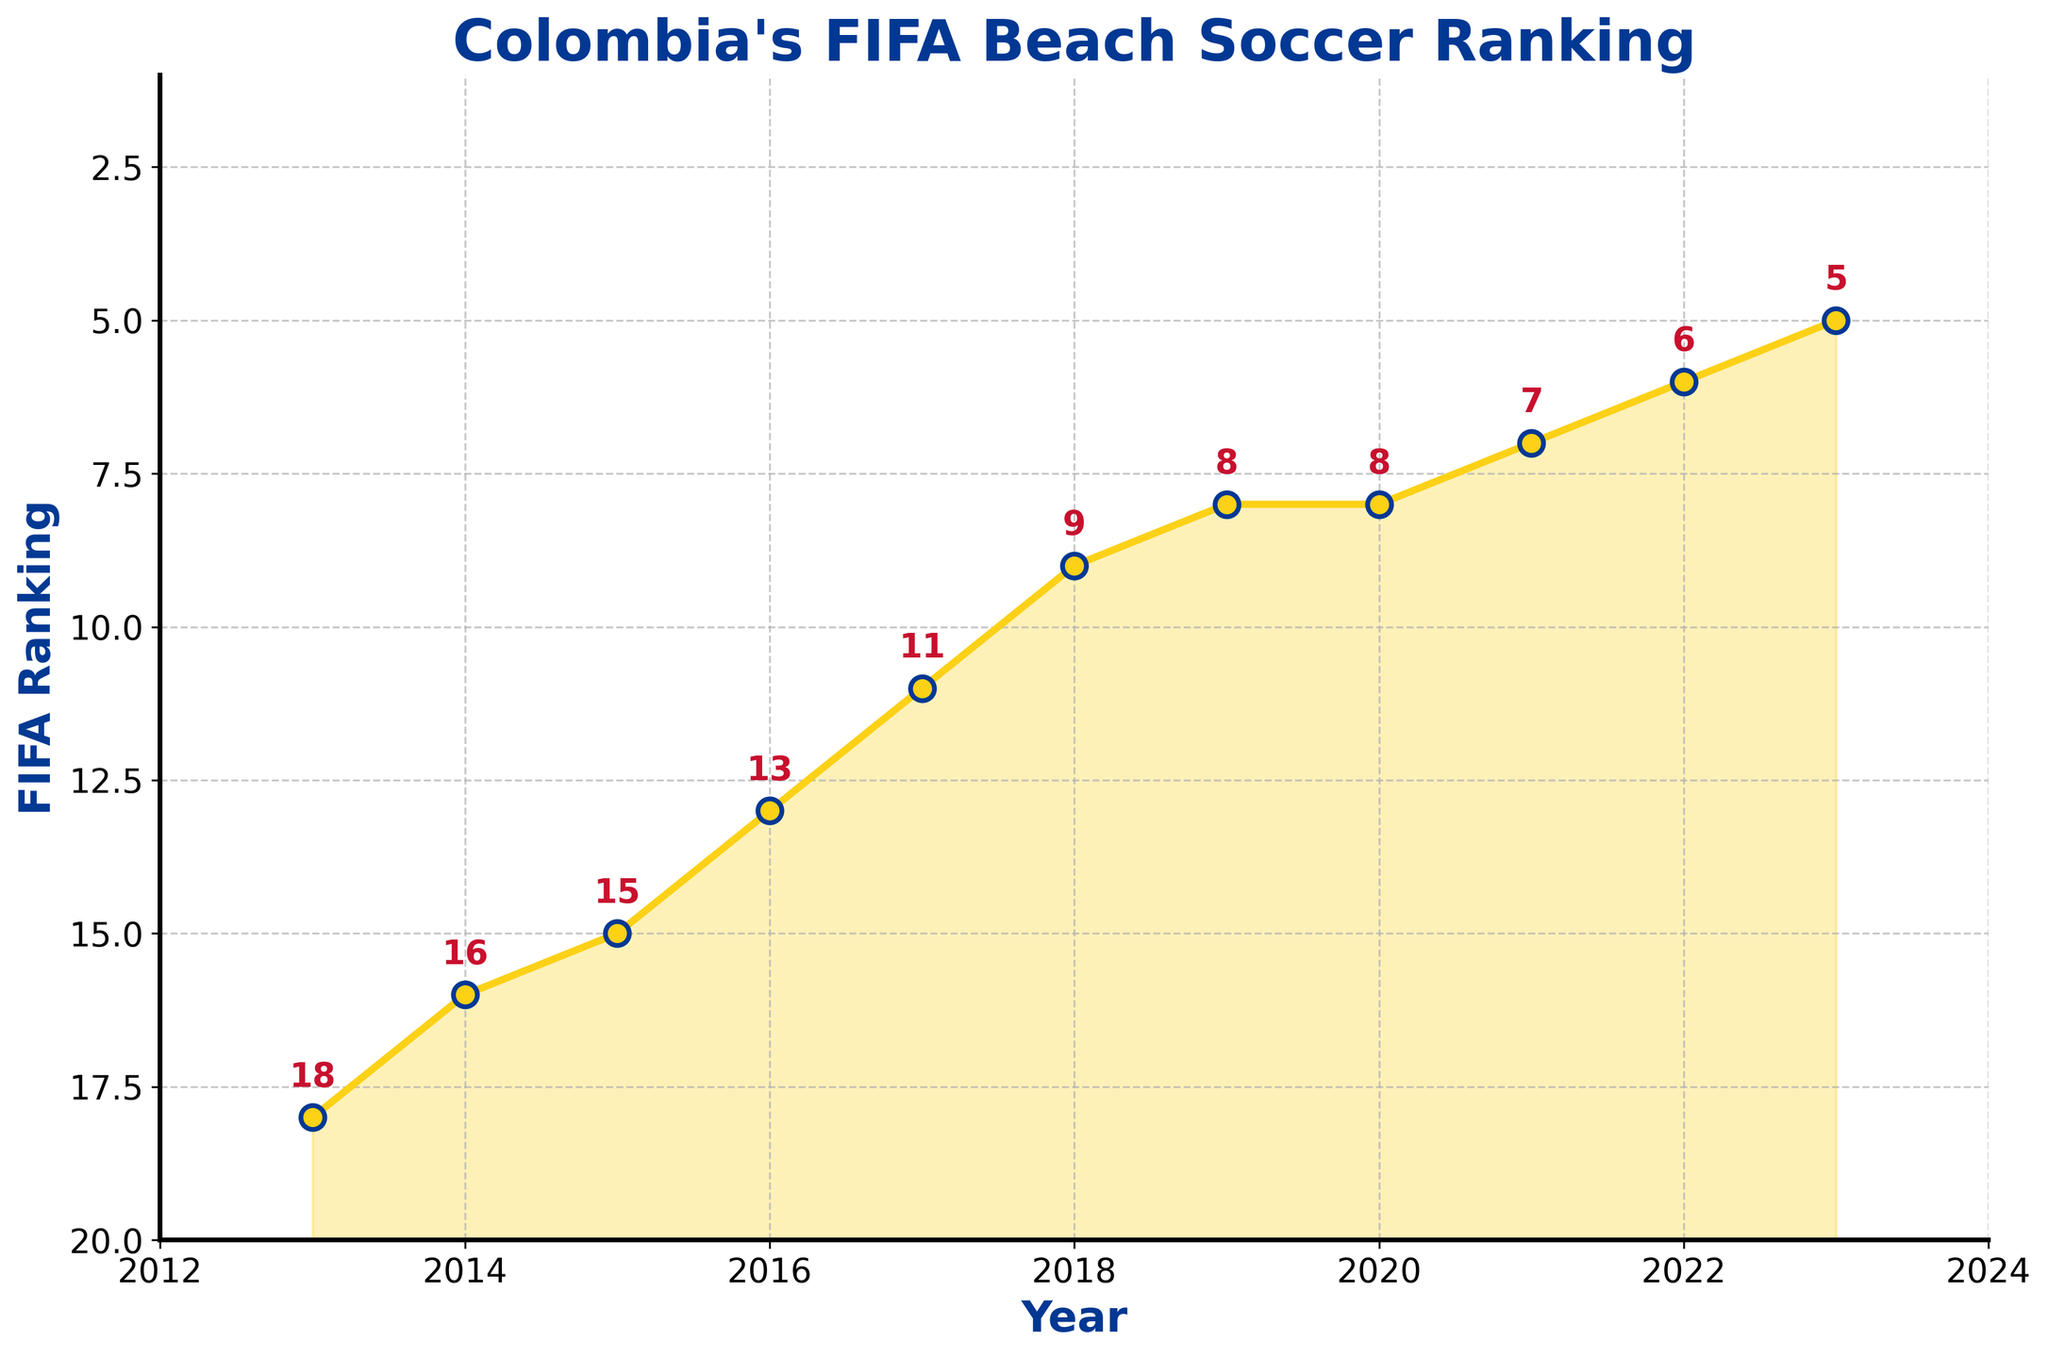What's the highest FIFA ranking that Colombia's beach soccer team achieved over the last decade? Looking at the figure, the lowest point on the y-axis which indicates the best ranking is in the year 2023, labeled as 5.
Answer: 5 How many years did Colombia maintain the same FIFA ranking without progressing or regressing? Observing the data points, Colombia maintained the same ranking for two consecutive years from 2019 to 2020, both at 8.
Answer: 2 years (2019-2020) Which year shows the most significant improvement in ranking compared to the previous year? From 2017 to 2018, Colombia's ranking improved from 11 to 9, which is a jump of 2 ranks. This is the largest improvement in a single year.
Answer: 2018 On average, how much did Colombia's ranking improve per year over the decade? Over 10 years (from 2013 to 2023), Colombia's ranking improved from 18 to 5, which is a total improvement of 13 ranks. Dividing this by the 10-year span, the average improvement is 1.3 ranks per year.
Answer: 1.3 ranks/year In which year did Colombia enter the top 10 FIFA rankings for beach soccer for the first time? Colombia first entered the top 10 in the year 2018 when their ranking improved to 9.
Answer: 2018 Compare Colombia's FIFA ranking progression between 2013 to 2017 and 2018 to 2023. Which period had a steeper trend of improvement? From 2013 to 2017, the ranking improved from 18 to 11 (7 ranks in total). From 2018 to 2023, the ranking improved from 9 to 5 (4 ranks in total). The first period (2013-2017) had a steeper improvement (7 ranks) compared to the second period (2018-2023) (4 ranks).
Answer: 2013-2017 How many times did Colombia rank slower than 10th place over the decade? Colombia ranked slower than 10th place from 2013 to 2017. This includes 5 years (2013, 2014, 2015, 2016, 2017).
Answer: 5 times What is the total number of years Colombia's FIFA ranking was in the single digits? Colombia's ranking was in the single digits from 2018 to 2023, which is 6 years.
Answer: 6 years What is the trend observed in Colombia's FIFA beach soccer rankings from 2013 to 2023? The trend shows a consistent improvement in Colombia's rankings, going from 18 in 2013 to 5 in 2023, indicating a marked upward trajectory in performance.
Answer: Consistent improvement Identify the year with minimal change in ranking compared to the previous year. The year 2020 saw no change in ranking compared to 2019, both years having a ranking of 8.
Answer: 2020 